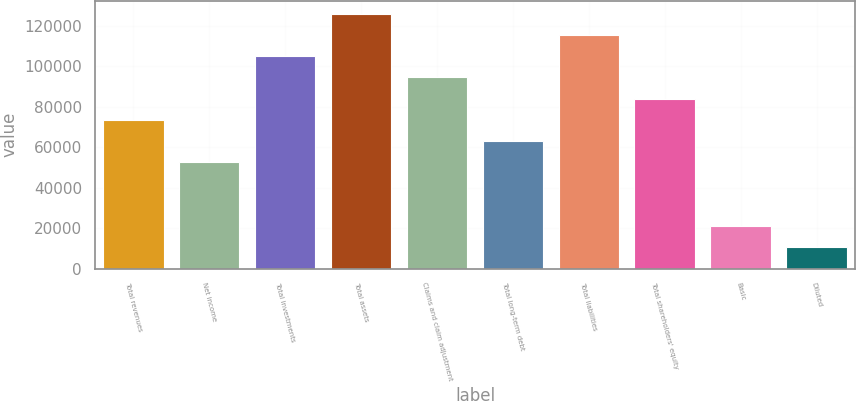Convert chart to OTSL. <chart><loc_0><loc_0><loc_500><loc_500><bar_chart><fcel>Total revenues<fcel>Net income<fcel>Total investments<fcel>Total assets<fcel>Claims and claim adjustment<fcel>Total long-term debt<fcel>Total liabilities<fcel>Total shareholders' equity<fcel>Basic<fcel>Diluted<nl><fcel>73627.1<fcel>52591.2<fcel>105181<fcel>126217<fcel>94663.1<fcel>63109.2<fcel>115699<fcel>84145.1<fcel>21037.3<fcel>10519.4<nl></chart> 